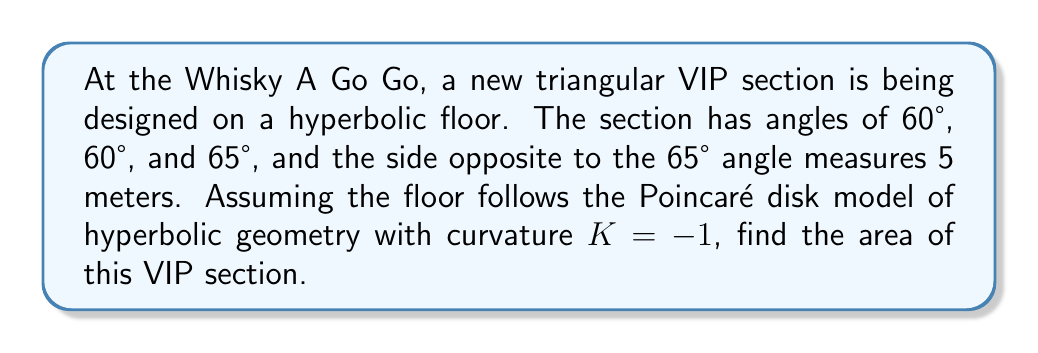Can you solve this math problem? Let's approach this step-by-step:

1) In hyperbolic geometry, the area of a triangle is given by the formula:

   $$A = (\alpha + \beta + \gamma - \pi) \cdot |K|^{-1}$$

   where $\alpha$, $\beta$, and $\gamma$ are the angles of the triangle, and $K$ is the curvature.

2) We're given that $K = -1$, so $|K|^{-1} = 1$.

3) Convert the angles to radians:
   60° = $\frac{\pi}{3}$ rad
   65° = $\frac{13\pi}{36}$ rad

4) Substitute into the formula:

   $$A = (\frac{\pi}{3} + \frac{\pi}{3} + \frac{13\pi}{36} - \pi) \cdot 1$$

5) Simplify:

   $$A = (\frac{12\pi}{36} + \frac{12\pi}{36} + \frac{13\pi}{36} - \frac{36\pi}{36}) \cdot 1$$
   $$A = \frac{37\pi}{36} - \pi = \frac{\pi}{36}$$

6) Convert to square meters:

   $$A \approx 0.0873 \text{ m}^2$$

Note: The side length given (5 meters) wasn't necessary for this calculation, as the area in hyperbolic geometry depends only on the angles.
Answer: $\frac{\pi}{36}$ or approximately 0.0873 m² 